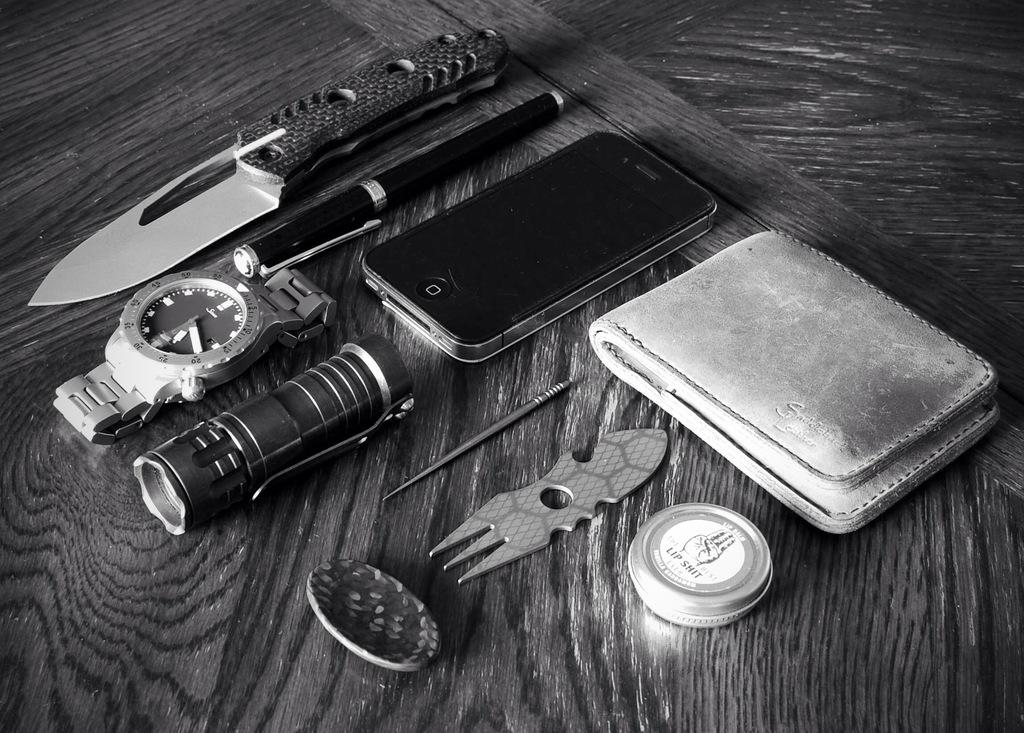<image>
Render a clear and concise summary of the photo. a watch that has the number 40 on it 